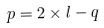<formula> <loc_0><loc_0><loc_500><loc_500>p = 2 \times l - q</formula> 